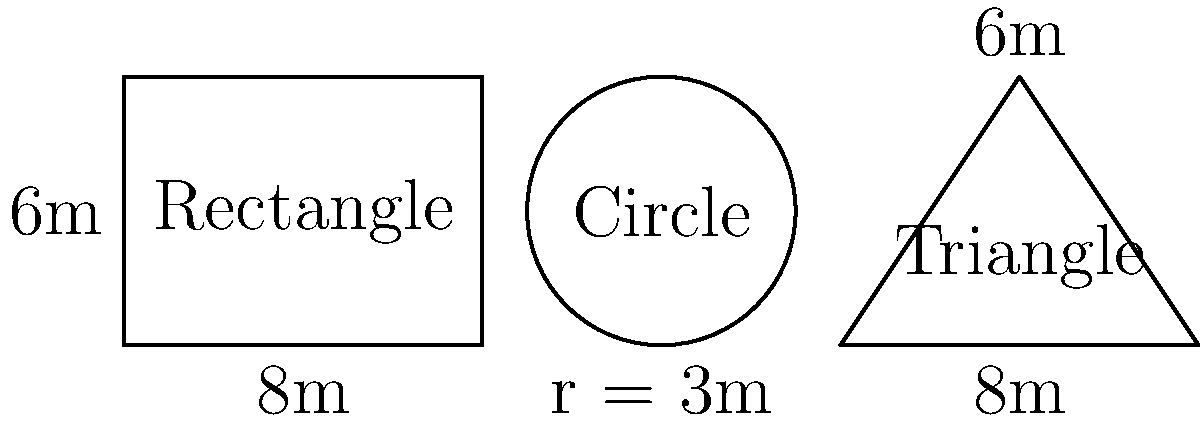As an event planner, you need to determine the maximum capacity for three different event spaces: a rectangular room, a circular room, and a triangular room. The rectangular room measures 8m x 6m, the circular room has a radius of 3m, and the triangular room has a base of 8m and a height of 6m. If safety regulations require 1.5 square meters per person, what is the total maximum capacity for all three rooms combined? Round down to the nearest whole number. Let's calculate the capacity for each room separately:

1. Rectangular room:
   Area = length × width
   $A_r = 8m \times 6m = 48m^2$
   Capacity = $\frac{48m^2}{1.5m^2/person} = 32$ people

2. Circular room:
   Area = $\pi r^2$
   $A_c = \pi \times (3m)^2 = 28.27m^2$
   Capacity = $\frac{28.27m^2}{1.5m^2/person} = 18.85$ people (round down to 18)

3. Triangular room:
   Area = $\frac{1}{2} \times base \times height$
   $A_t = \frac{1}{2} \times 8m \times 6m = 24m^2$
   Capacity = $\frac{24m^2}{1.5m^2/person} = 16$ people

Total maximum capacity:
32 + 18 + 16 = 66 people
Answer: 66 people 